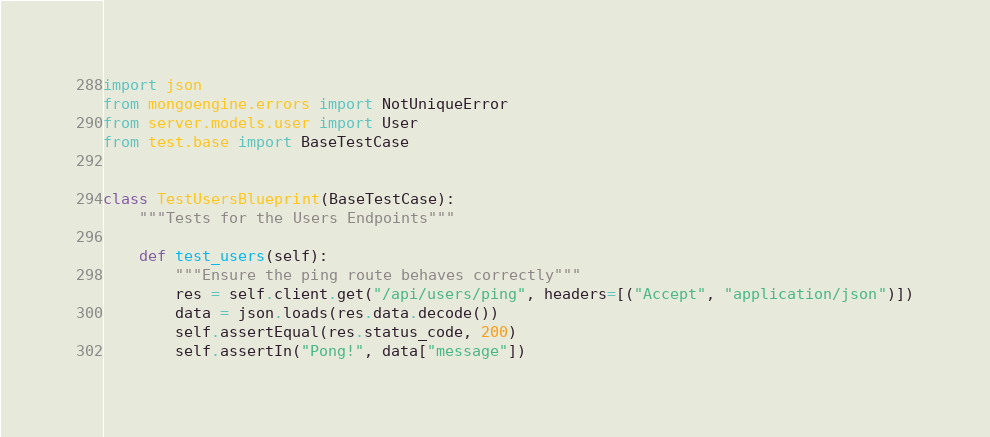Convert code to text. <code><loc_0><loc_0><loc_500><loc_500><_Python_>import json
from mongoengine.errors import NotUniqueError
from server.models.user import User
from test.base import BaseTestCase


class TestUsersBlueprint(BaseTestCase):
    """Tests for the Users Endpoints"""

    def test_users(self):
        """Ensure the ping route behaves correctly"""
        res = self.client.get("/api/users/ping", headers=[("Accept", "application/json")])
        data = json.loads(res.data.decode())
        self.assertEqual(res.status_code, 200)
        self.assertIn("Pong!", data["message"])
</code> 